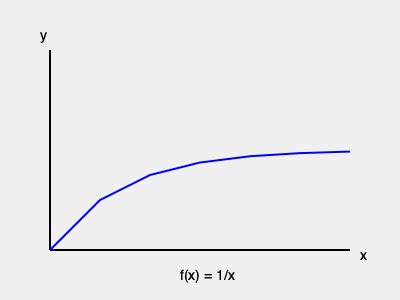Consider the graph of $f(x) = \frac{1}{x}$ for $x \geq 1$. Does the improper integral $\int_{1}^{\infty} \frac{1}{x} dx$ converge? If so, what does this imply about the convergence of the harmonic series $\sum_{n=1}^{\infty} \frac{1}{n}$? Let's approach this step-by-step:

1) First, we need to evaluate the improper integral $\int_{1}^{\infty} \frac{1}{x} dx$:

   $$\int_{1}^{\infty} \frac{1}{x} dx = \lim_{b \to \infty} \int_{1}^{b} \frac{1}{x} dx$$

2) Evaluating the indefinite integral:

   $$\int \frac{1}{x} dx = \ln|x| + C$$

3) Applying the limits:

   $$\lim_{b \to \infty} \int_{1}^{b} \frac{1}{x} dx = \lim_{b \to \infty} [\ln|x|]_{1}^{b} = \lim_{b \to \infty} (\ln b - \ln 1) = \infty$$

4) Therefore, the improper integral diverges.

5) Now, let's consider the harmonic series $\sum_{n=1}^{\infty} \frac{1}{n}$. We can relate this to our integral using the integral test:

   $$\sum_{n=1}^{\infty} \frac{1}{n} \text{ converges if and only if } \int_{1}^{\infty} \frac{1}{x} dx \text{ converges}$$

6) Since we've shown that $\int_{1}^{\infty} \frac{1}{x} dx$ diverges, we can conclude that the harmonic series $\sum_{n=1}^{\infty} \frac{1}{n}$ also diverges.

7) This aligns with the graph, which shows that while $f(x) = \frac{1}{x}$ approaches 0 as x increases, the area under the curve from 1 to infinity is unbounded.
Answer: The improper integral diverges, implying the harmonic series also diverges. 